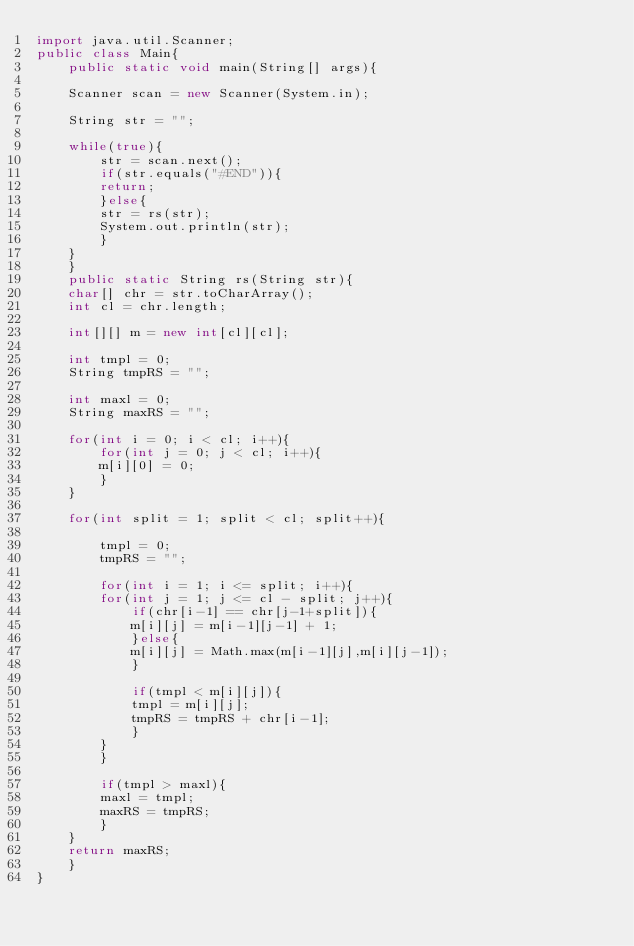<code> <loc_0><loc_0><loc_500><loc_500><_Java_>import java.util.Scanner;
public class Main{
    public static void main(String[] args){
	
	Scanner scan = new Scanner(System.in);
	
	String str = "";
	
	while(true){
	    str = scan.next();
	    if(str.equals("#END")){
		return;
	    }else{
		str = rs(str);
		System.out.println(str);
	    }	    
	}
    }
    public static String rs(String str){
	char[] chr = str.toCharArray();
	int cl = chr.length;

	int[][] m = new int[cl][cl];

	int tmpl = 0;
	String tmpRS = "";

	int maxl = 0;
	String maxRS = "";

	for(int i = 0; i < cl; i++){
	    for(int j = 0; j < cl; i++){
		m[i][0] = 0;
	    }
	}
	
	for(int split = 1; split < cl; split++){
	    
	    tmpl = 0;
	    tmpRS = "";
	    
	    for(int i = 1; i <= split; i++){
		for(int j = 1; j <= cl - split; j++){
		    if(chr[i-1] == chr[j-1+split]){
			m[i][j] = m[i-1][j-1] + 1;
		    }else{
			m[i][j] = Math.max(m[i-1][j],m[i][j-1]);
		    }
		
		    if(tmpl < m[i][j]){
			tmpl = m[i][j];
			tmpRS = tmpRS + chr[i-1];
		    }
		}
	    }
	    
	    if(tmpl > maxl){
		maxl = tmpl;
		maxRS = tmpRS;
	    }	    
	}
	return maxRS;
    }
}</code> 